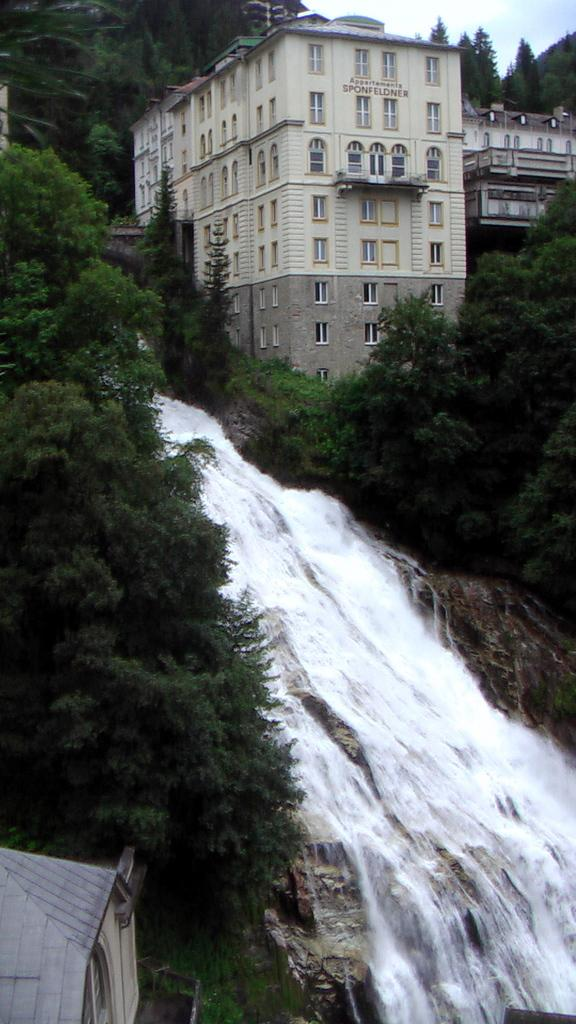What is the main feature in the foreground of the image? There is a waterfall in the foreground of the image. What can be seen on the left side of the image? There are trees on the left side of the image. What structure is located at the bottom of the trees? There is a house at the bottom of the trees. What is visible in the background of the image? There are buildings, trees, and the sky visible in the background of the image. What type of disease is being treated at the dock in the image? There is no dock present in the image, and therefore no disease treatment can be observed. 